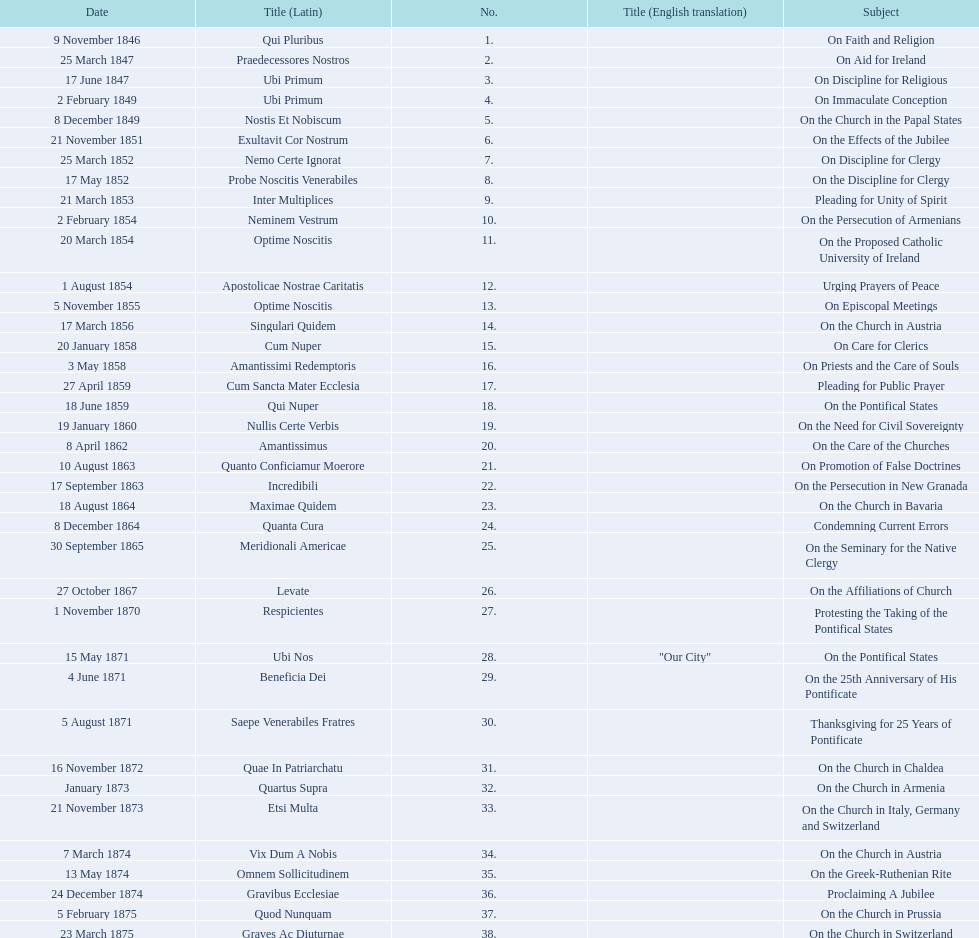Date of the last encyclical whose subject contained the word "pontificate" 5 August 1871. 